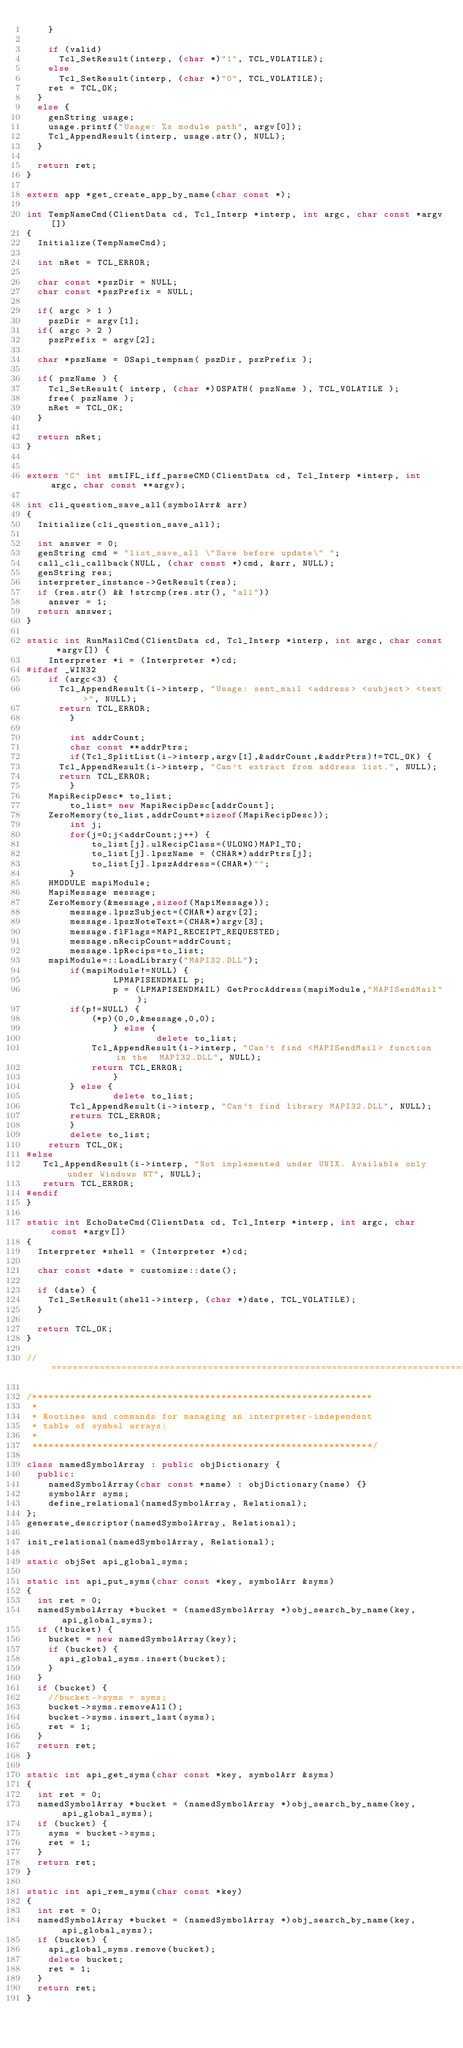Convert code to text. <code><loc_0><loc_0><loc_500><loc_500><_C++_>    }

    if (valid)
      Tcl_SetResult(interp, (char *)"1", TCL_VOLATILE);
    else
      Tcl_SetResult(interp, (char *)"0", TCL_VOLATILE);
    ret = TCL_OK;
  }
  else {
    genString usage;
    usage.printf("Usage: %s module path", argv[0]);
    Tcl_AppendResult(interp, usage.str(), NULL);
  }
  
  return ret;
}

extern app *get_create_app_by_name(char const *);

int TempNameCmd(ClientData cd, Tcl_Interp *interp, int argc, char const *argv[])
{
  Initialize(TempNameCmd);

  int nRet = TCL_ERROR;
  
  char const *pszDir = NULL;
  char const *pszPrefix = NULL;
  
  if( argc > 1 )
    pszDir = argv[1];
  if( argc > 2 )
    pszPrefix = argv[2];
  
  char *pszName = OSapi_tempnam( pszDir, pszPrefix );

  if( pszName ) {
    Tcl_SetResult( interp, (char *)OSPATH( pszName ), TCL_VOLATILE );
    free( pszName );
    nRet = TCL_OK;
  }

  return nRet;
}


extern "C" int smtIFL_iff_parseCMD(ClientData cd, Tcl_Interp *interp, int argc, char const **argv);

int cli_question_save_all(symbolArr& arr)
{
  Initialize(cli_question_save_all);

  int answer = 0; 
  genString cmd = "list_save_all \"Save before update\" ";
  call_cli_callback(NULL, (char const *)cmd, &arr, NULL);
  genString res;
  interpreter_instance->GetResult(res);
  if (res.str() && !strcmp(res.str(), "all"))
    answer = 1;
  return answer;
}

static int RunMailCmd(ClientData cd, Tcl_Interp *interp, int argc, char const *argv[]) {
    Interpreter *i = (Interpreter *)cd;
#ifdef _WIN32
    if (argc<3) {
      Tcl_AppendResult(i->interp, "Usage: sent_mail <address> <subject> <text>", NULL);
      return TCL_ERROR;
        }

        int addrCount;
        char const **addrPtrs;
        if(Tcl_SplitList(i->interp,argv[1],&addrCount,&addrPtrs)!=TCL_OK) {
      Tcl_AppendResult(i->interp, "Can't extract from address list.", NULL);
      return TCL_ERROR;
        }
    MapiRecipDesc* to_list;
        to_list= new MapiRecipDesc[addrCount];
    ZeroMemory(to_list,addrCount*sizeof(MapiRecipDesc));
        int j;
        for(j=0;j<addrCount;j++) {
            to_list[j].ulRecipClass=(ULONG)MAPI_TO;
            to_list[j].lpszName = (CHAR*)addrPtrs[j];
            to_list[j].lpszAddress=(CHAR*)"";
        }
    HMODULE mapiModule;
    MapiMessage message;
    ZeroMemory(&message,sizeof(MapiMessage));
        message.lpszSubject=(CHAR*)argv[2];
        message.lpszNoteText=(CHAR*)argv[3];
        message.flFlags=MAPI_RECEIPT_REQUESTED;
        message.nRecipCount=addrCount;
        message.lpRecips=to_list;
    mapiModule=::LoadLibrary("MAPI32.DLL");
        if(mapiModule!=NULL) {
                LPMAPISENDMAIL p;
                p = (LPMAPISENDMAIL) GetProcAddress(mapiModule,"MAPISendMail");
        if(p!=NULL) {
            (*p)(0,0,&message,0,0);
                } else {
                        delete to_list;
            Tcl_AppendResult(i->interp, "Can't find <MAPISendMail> function in the  MAPI32.DLL", NULL);
            return TCL_ERROR;
                }
        } else {
                delete to_list;
        Tcl_AppendResult(i->interp, "Can't find library MAPI32.DLL", NULL);
        return TCL_ERROR;
        }
        delete to_list;
    return TCL_OK;
#else 
   Tcl_AppendResult(i->interp, "Not implemented under UNIX. Available only under Windows NT", NULL);
   return TCL_ERROR;
#endif
}

static int EchoDateCmd(ClientData cd, Tcl_Interp *interp, int argc, char const *argv[])
{
  Interpreter *shell = (Interpreter *)cd;

  char const *date = customize::date();

  if (date) {
    Tcl_SetResult(shell->interp, (char *)date, TCL_VOLATILE);
  }

  return TCL_OK;
}

//==============================================================================

/***************************************************************
 *
 * Routines and commands for managing an interpreter-independent
 * table of symbol arrays:
 *
 ***************************************************************/

class namedSymbolArray : public objDictionary {
  public:
    namedSymbolArray(char const *name) : objDictionary(name) {}
    symbolArr syms;
    define_relational(namedSymbolArray, Relational);
};
generate_descriptor(namedSymbolArray, Relational);

init_relational(namedSymbolArray, Relational);

static objSet api_global_syms;

static int api_put_syms(char const *key, symbolArr &syms)
{
  int ret = 0;
  namedSymbolArray *bucket = (namedSymbolArray *)obj_search_by_name(key, api_global_syms);
  if (!bucket) {
    bucket = new namedSymbolArray(key);
    if (bucket) {
      api_global_syms.insert(bucket);
    }
  }
  if (bucket) {
    //bucket->syms = syms;
    bucket->syms.removeAll();
    bucket->syms.insert_last(syms);
    ret = 1;
  }
  return ret;
}

static int api_get_syms(char const *key, symbolArr &syms)
{
  int ret = 0;
  namedSymbolArray *bucket = (namedSymbolArray *)obj_search_by_name(key, api_global_syms);
  if (bucket) {
    syms = bucket->syms;
    ret = 1;
  }
  return ret;
}

static int api_rem_syms(char const *key)
{
  int ret = 0;
  namedSymbolArray *bucket = (namedSymbolArray *)obj_search_by_name(key, api_global_syms);
  if (bucket) {
    api_global_syms.remove(bucket);
    delete bucket;
    ret = 1;
  }
  return ret;
}
</code> 